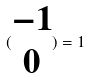Convert formula to latex. <formula><loc_0><loc_0><loc_500><loc_500>( \begin{matrix} - 1 \\ 0 \end{matrix} ) = 1</formula> 